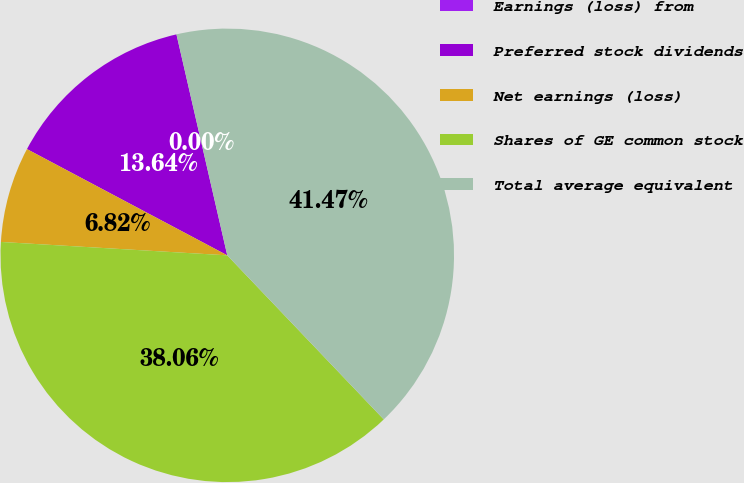Convert chart. <chart><loc_0><loc_0><loc_500><loc_500><pie_chart><fcel>Earnings (loss) from<fcel>Preferred stock dividends<fcel>Net earnings (loss)<fcel>Shares of GE common stock<fcel>Total average equivalent<nl><fcel>0.0%<fcel>13.64%<fcel>6.82%<fcel>38.06%<fcel>41.47%<nl></chart> 